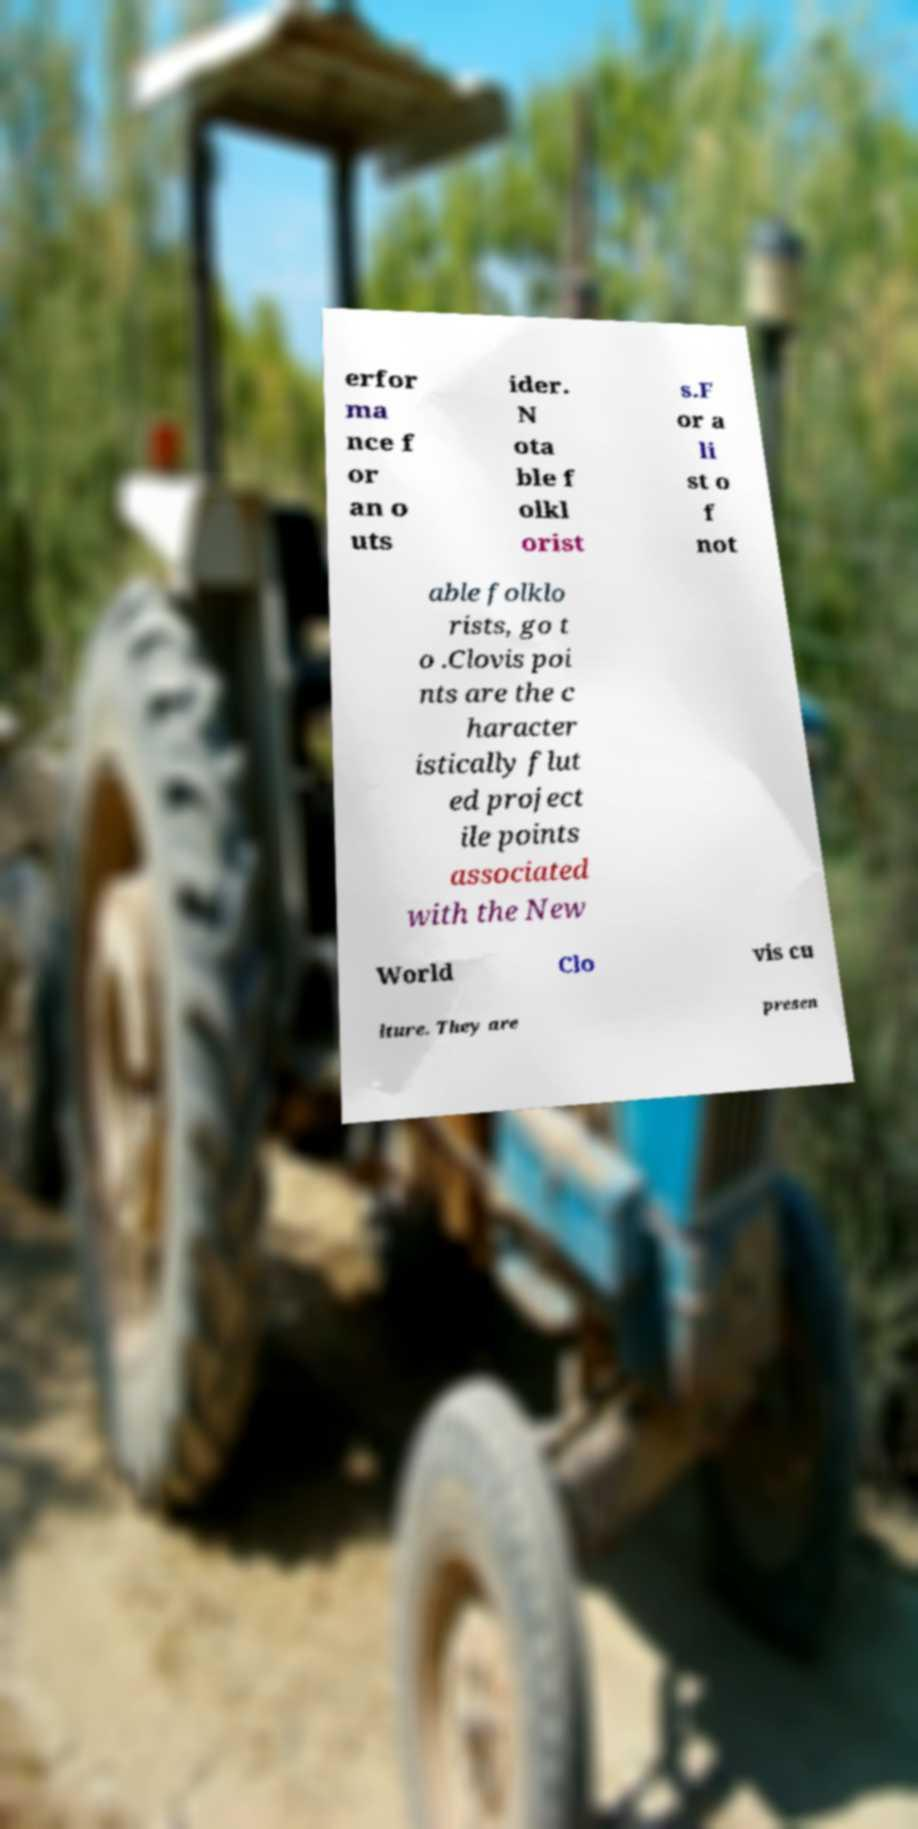Can you read and provide the text displayed in the image?This photo seems to have some interesting text. Can you extract and type it out for me? erfor ma nce f or an o uts ider. N ota ble f olkl orist s.F or a li st o f not able folklo rists, go t o .Clovis poi nts are the c haracter istically flut ed project ile points associated with the New World Clo vis cu lture. They are presen 